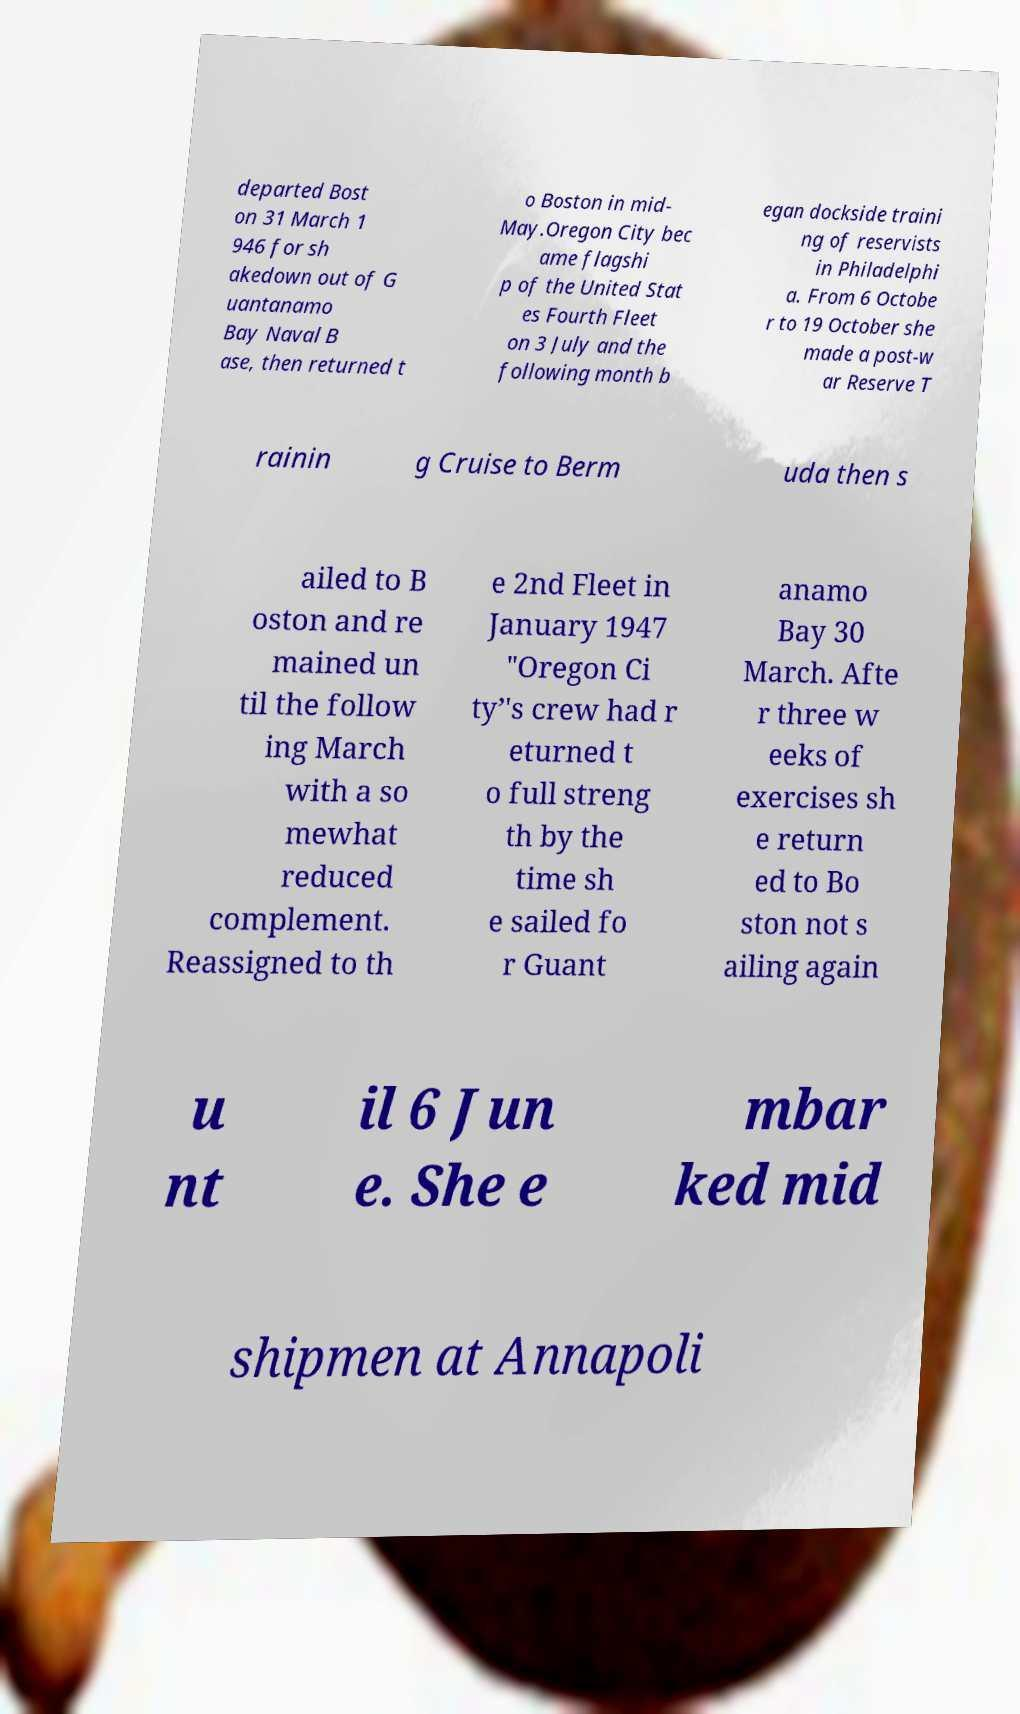What messages or text are displayed in this image? I need them in a readable, typed format. departed Bost on 31 March 1 946 for sh akedown out of G uantanamo Bay Naval B ase, then returned t o Boston in mid- May.Oregon City bec ame flagshi p of the United Stat es Fourth Fleet on 3 July and the following month b egan dockside traini ng of reservists in Philadelphi a. From 6 Octobe r to 19 October she made a post-w ar Reserve T rainin g Cruise to Berm uda then s ailed to B oston and re mained un til the follow ing March with a so mewhat reduced complement. Reassigned to th e 2nd Fleet in January 1947 "Oregon Ci ty’'s crew had r eturned t o full streng th by the time sh e sailed fo r Guant anamo Bay 30 March. Afte r three w eeks of exercises sh e return ed to Bo ston not s ailing again u nt il 6 Jun e. She e mbar ked mid shipmen at Annapoli 